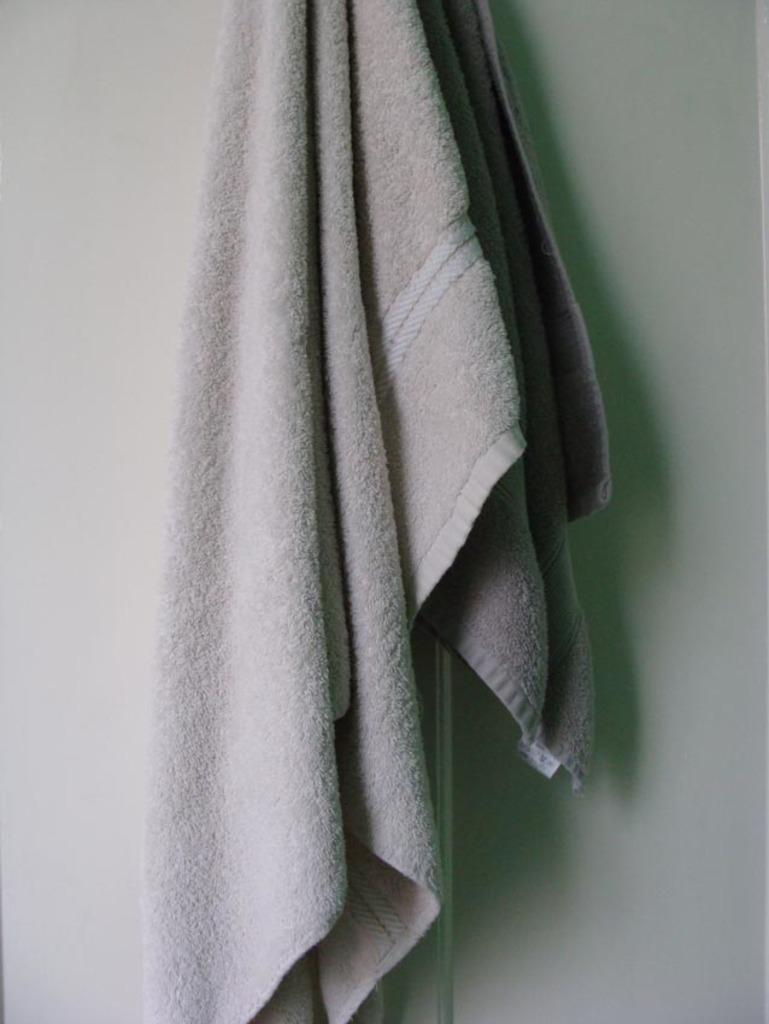What is located in the center of the image? There is a wall in the center of the image. What is hanging on the wall? There is a towel on the wall. What type of suit is hanging on the wall in the image? There is no suit present in the image; it only features a wall with a towel on it. 